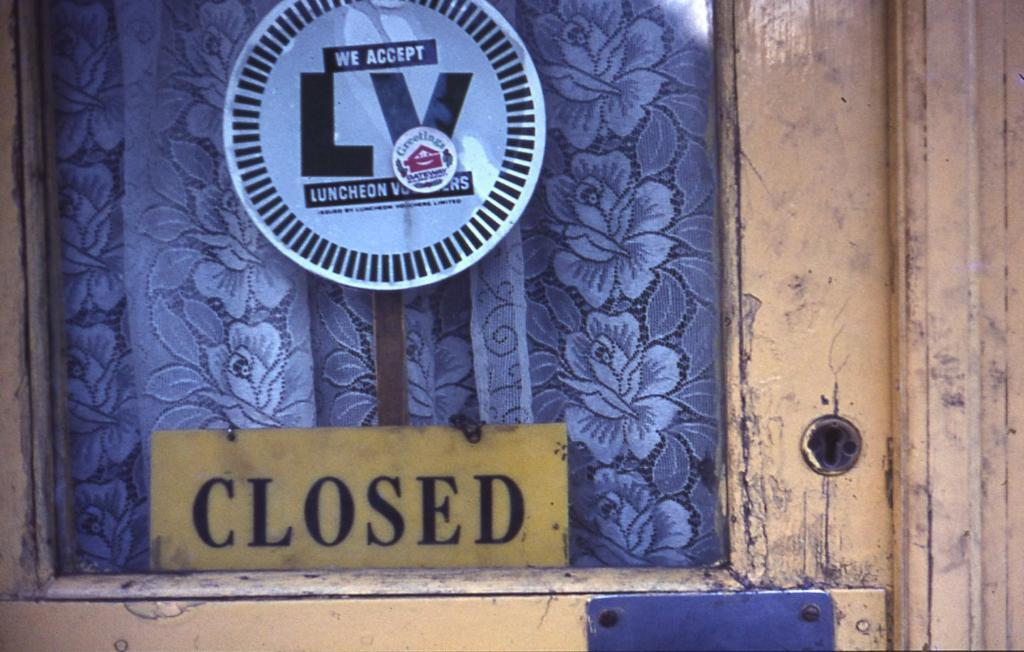<image>
Describe the image concisely. Blue cover and a yellow sign that says CLOSED. 